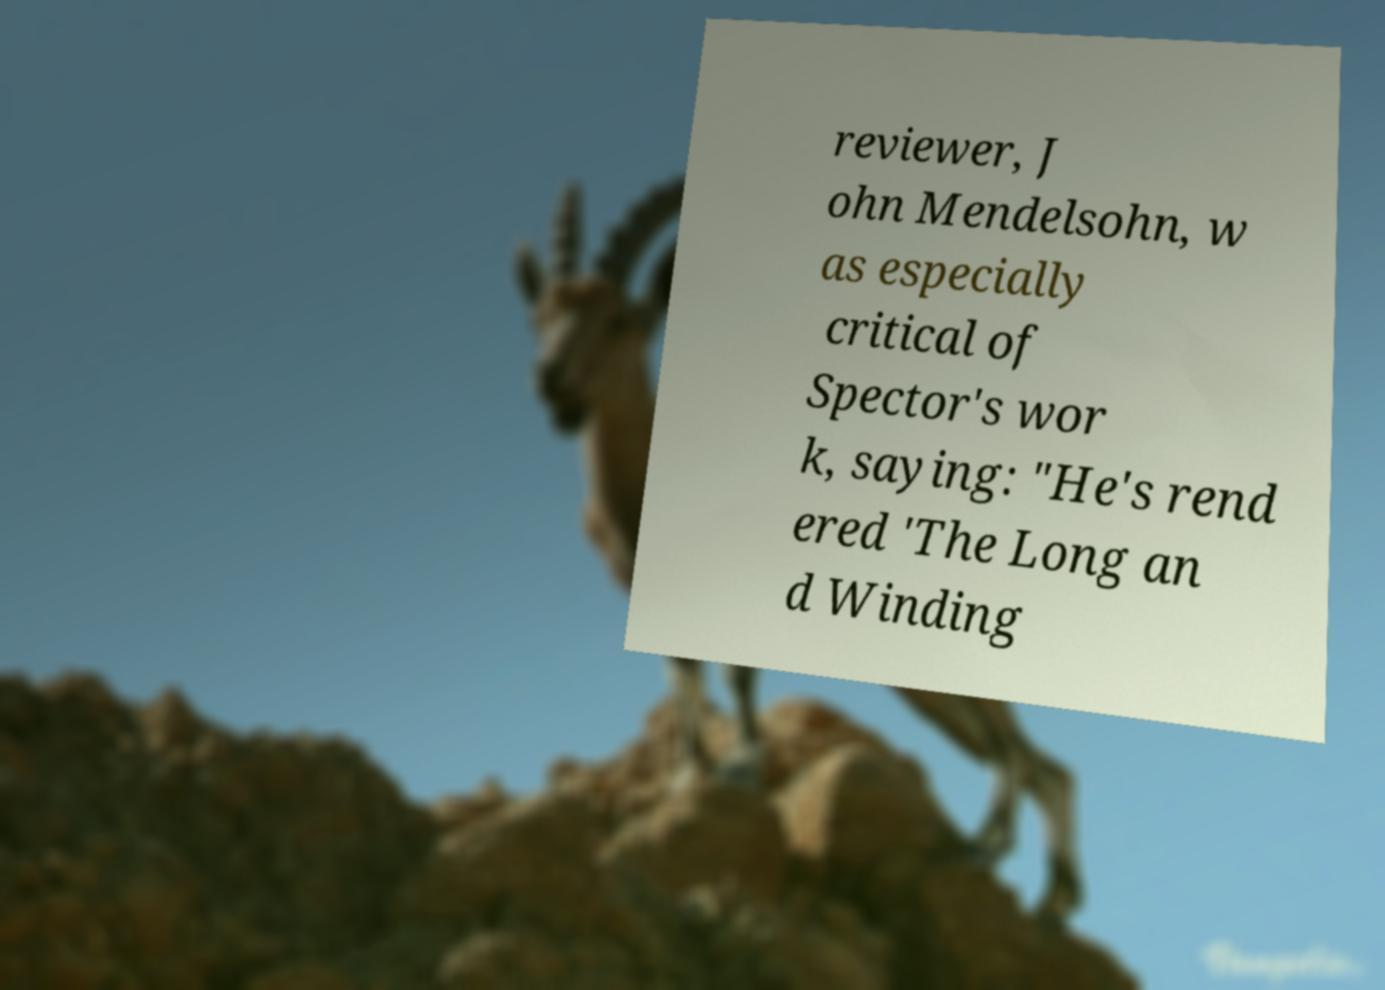Could you assist in decoding the text presented in this image and type it out clearly? reviewer, J ohn Mendelsohn, w as especially critical of Spector's wor k, saying: "He's rend ered 'The Long an d Winding 